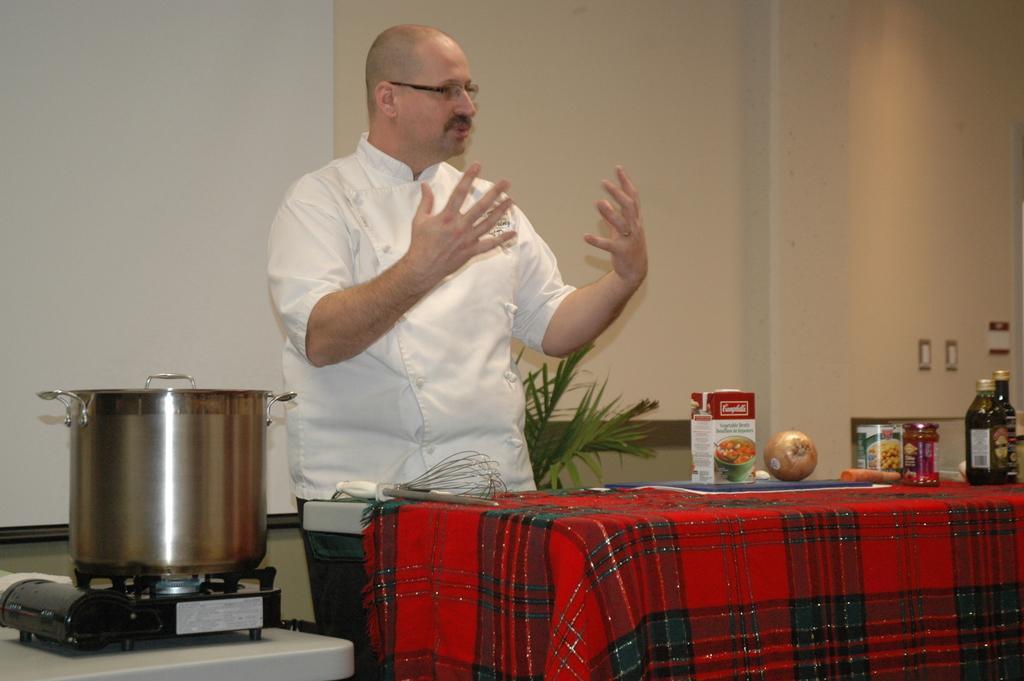Could you give a brief overview of what you see in this image? In this picture I can observe a person standing in front of a table wearing white color dress and spectacles. On the table I can observe few things. On the left side I can observe a stove. In the background there is a wall. 